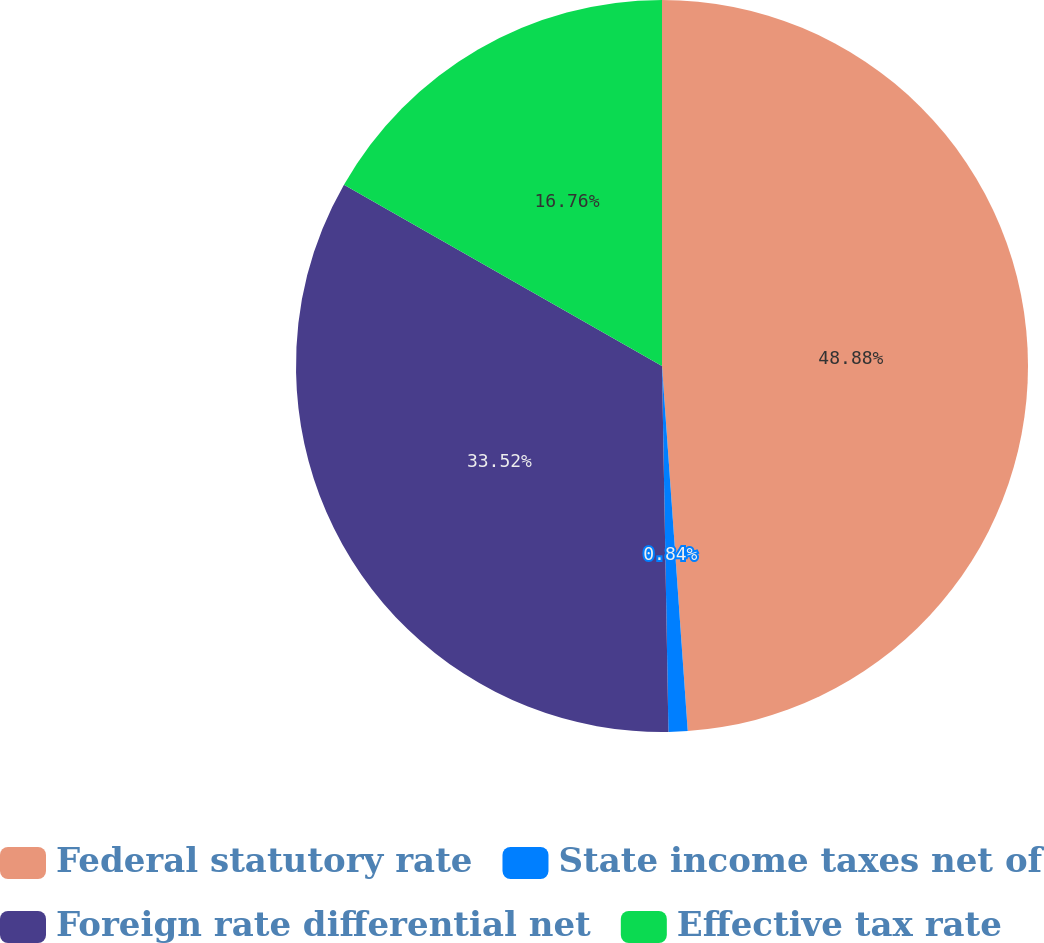Convert chart to OTSL. <chart><loc_0><loc_0><loc_500><loc_500><pie_chart><fcel>Federal statutory rate<fcel>State income taxes net of<fcel>Foreign rate differential net<fcel>Effective tax rate<nl><fcel>48.88%<fcel>0.84%<fcel>33.52%<fcel>16.76%<nl></chart> 